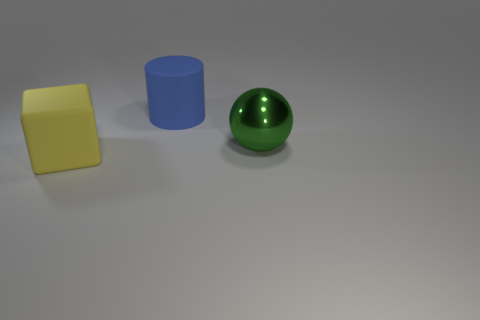Do the big blue thing and the large yellow object have the same shape?
Offer a very short reply. No. What number of objects are big rubber objects left of the big blue matte object or tiny purple rubber balls?
Provide a short and direct response. 1. There is another object that is made of the same material as the big yellow thing; what size is it?
Offer a terse response. Large. How many rubber objects are the same color as the rubber block?
Your answer should be compact. 0. What number of large things are either green balls or matte cylinders?
Provide a short and direct response. 2. Are there any large purple blocks made of the same material as the large blue thing?
Keep it short and to the point. No. There is a big thing on the left side of the big blue object; what is its material?
Provide a short and direct response. Rubber. There is a big rubber object on the left side of the big blue object; is it the same color as the large thing to the right of the rubber cylinder?
Your answer should be very brief. No. What is the color of the cube that is the same size as the green thing?
Give a very brief answer. Yellow. How many other things are there of the same shape as the green metallic object?
Ensure brevity in your answer.  0. 